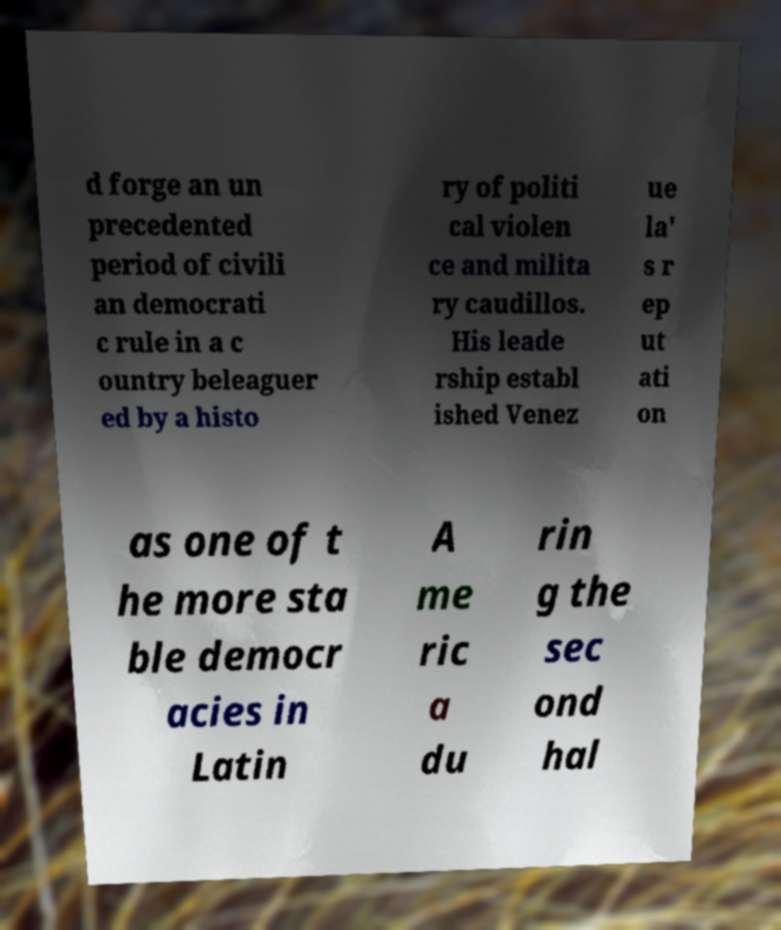Please identify and transcribe the text found in this image. d forge an un precedented period of civili an democrati c rule in a c ountry beleaguer ed by a histo ry of politi cal violen ce and milita ry caudillos. His leade rship establ ished Venez ue la' s r ep ut ati on as one of t he more sta ble democr acies in Latin A me ric a du rin g the sec ond hal 